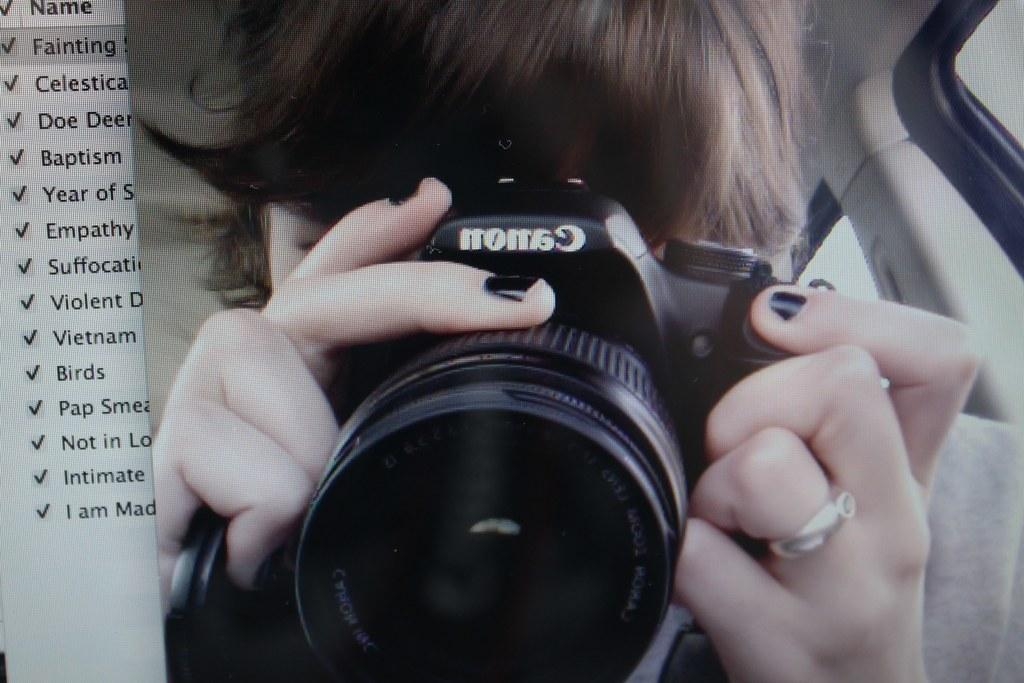What is the main subject of the image? There is a person in the image. What is the person holding in the image? The person is holding a camera. What can be seen on the right side of the image? There is a window on the right side of the image. What is present on the left side of the image? There is text on the left side of the image. What type of crook can be seen in the image? There is no crook present in the image. Can you tell me how many airplanes are visible in the image? There are no airplanes visible in the image. 